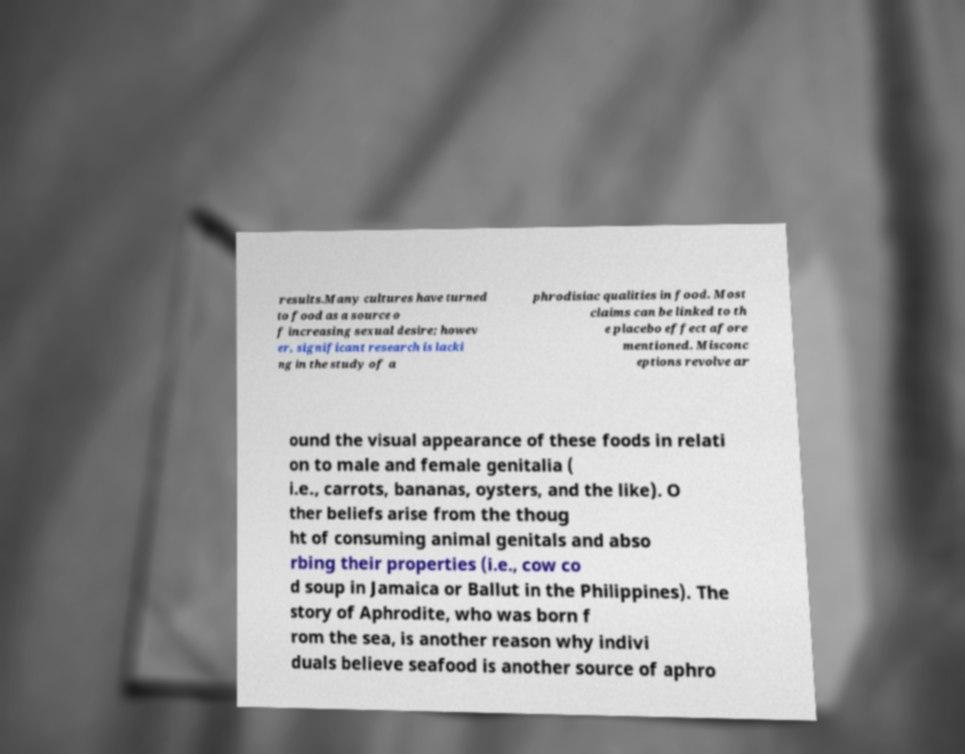Please identify and transcribe the text found in this image. results.Many cultures have turned to food as a source o f increasing sexual desire; howev er, significant research is lacki ng in the study of a phrodisiac qualities in food. Most claims can be linked to th e placebo effect afore mentioned. Misconc eptions revolve ar ound the visual appearance of these foods in relati on to male and female genitalia ( i.e., carrots, bananas, oysters, and the like). O ther beliefs arise from the thoug ht of consuming animal genitals and abso rbing their properties (i.e., cow co d soup in Jamaica or Ballut in the Philippines). The story of Aphrodite, who was born f rom the sea, is another reason why indivi duals believe seafood is another source of aphro 